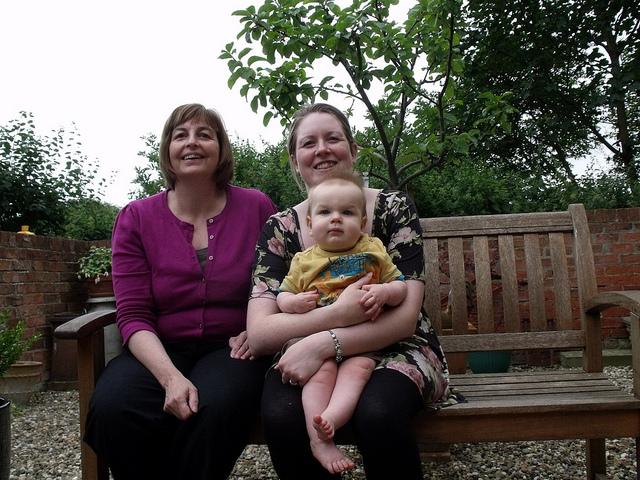What print is the woman wearing?
Concise answer only. Floral. Where are they sitting?
Short answer required. On bench. What is this child sitting on?
Short answer required. Lap. What color is the child's shirt?
Quick response, please. Yellow. What is the woman holding in the hand?
Write a very short answer. Baby. Which stage of life is the person in the yellow shirt in?
Give a very brief answer. Baby. Are any adults with this child?
Be succinct. Yes. Is the older woman from this place?
Answer briefly. Yes. How many people are on this bench?
Keep it brief. 3. 